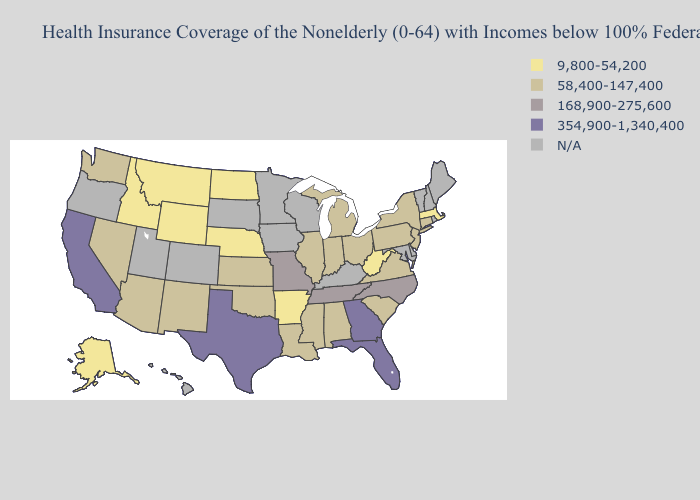Name the states that have a value in the range 168,900-275,600?
Quick response, please. Missouri, North Carolina, Tennessee. Among the states that border Missouri , does Illinois have the highest value?
Write a very short answer. No. What is the lowest value in the MidWest?
Answer briefly. 9,800-54,200. What is the value of Nebraska?
Quick response, please. 9,800-54,200. Does California have the highest value in the USA?
Keep it brief. Yes. Name the states that have a value in the range 168,900-275,600?
Short answer required. Missouri, North Carolina, Tennessee. Which states have the lowest value in the South?
Quick response, please. Arkansas, West Virginia. Among the states that border New Hampshire , which have the lowest value?
Keep it brief. Massachusetts. Does Massachusetts have the lowest value in the Northeast?
Keep it brief. Yes. Which states have the highest value in the USA?
Answer briefly. California, Florida, Georgia, Texas. What is the value of South Dakota?
Answer briefly. N/A. Does Illinois have the highest value in the MidWest?
Write a very short answer. No. Which states hav the highest value in the MidWest?
Concise answer only. Missouri. What is the lowest value in states that border Kentucky?
Short answer required. 9,800-54,200. 